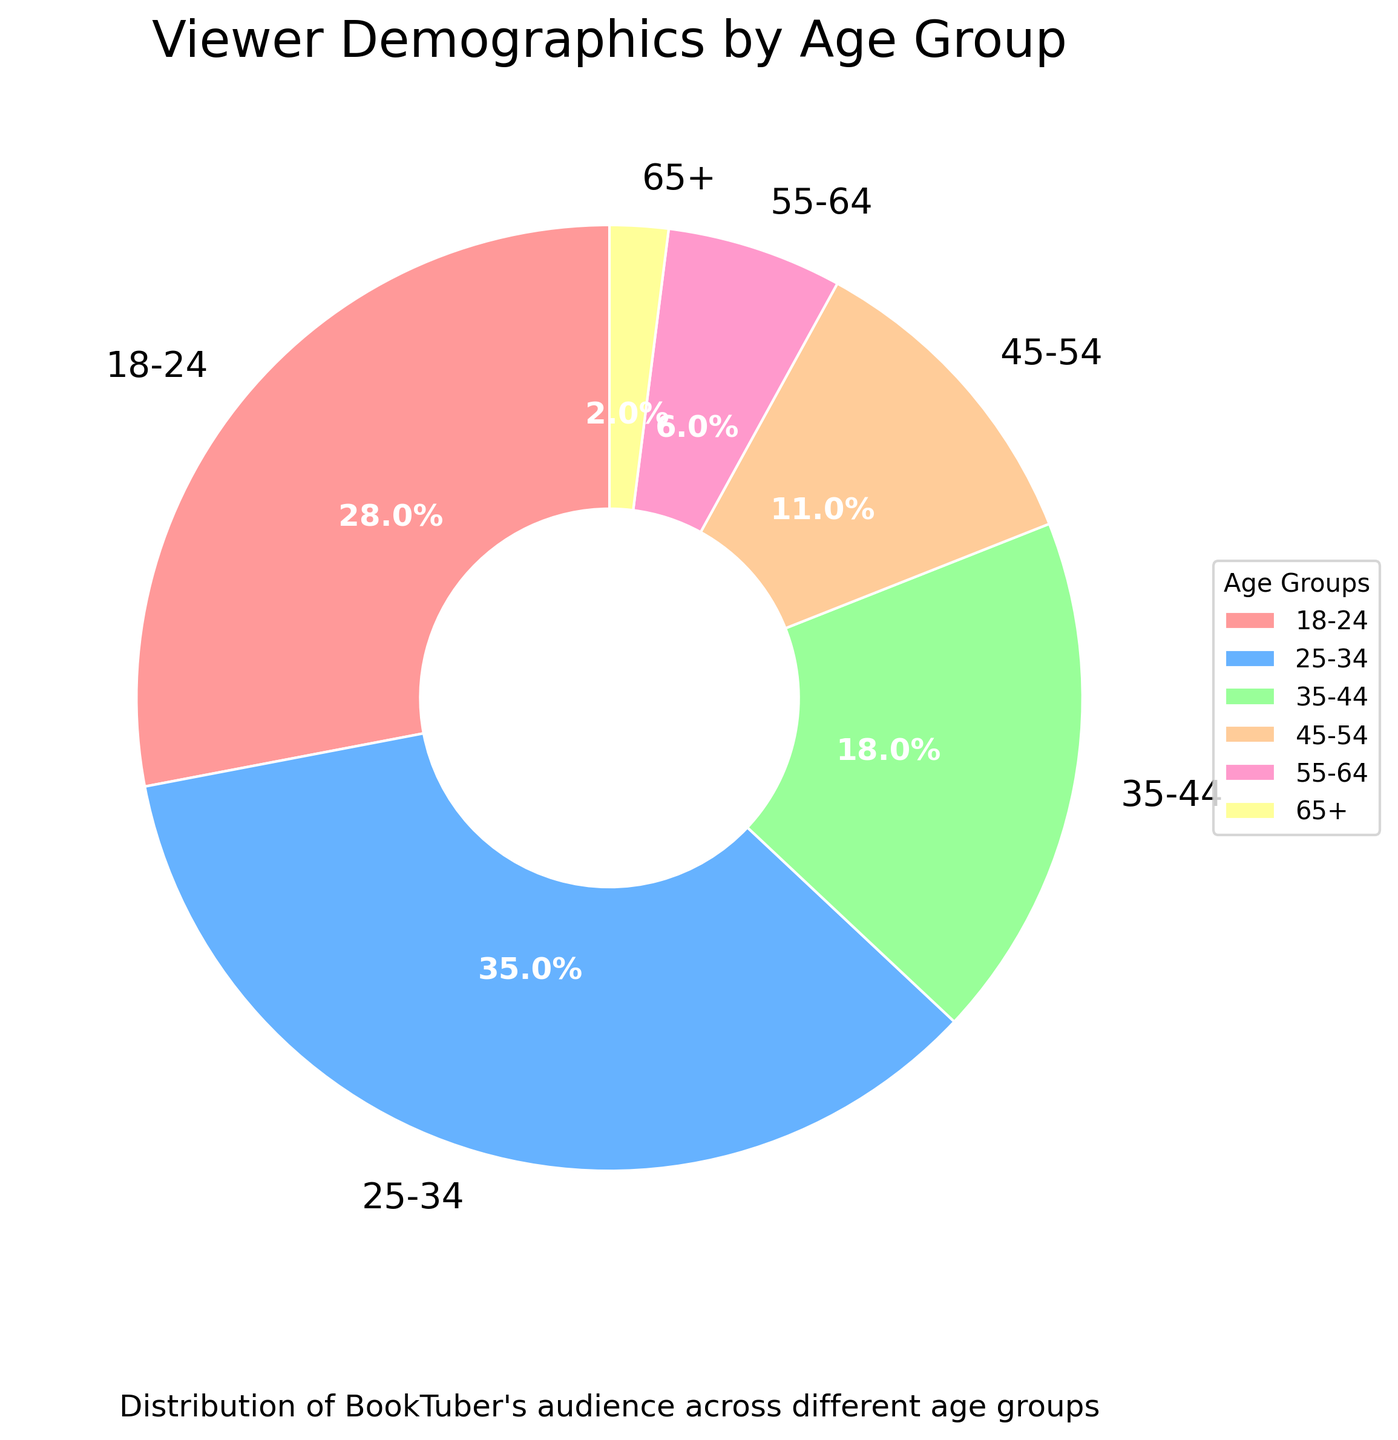What percentage of viewers are aged between 18 and 24? The figure shows the percentage distribution of viewers across different age groups. Locate the segment labeled "18-24" and refer to the associated percentage.
Answer: 28% Which age group constitutes the largest portion of the audience? Look at the pie chart and identify the segment with the largest size by comparing the relative areas of the segments. The label indicates that the 25-34 age group has the largest percentage.
Answer: 25-34 What is the combined percentage of viewers who are over 45 years old? To find the combined percentage of viewers over 45, add up the percentages of the 45-54, 55-64, and 65+ age groups. From the chart, these are 11%, 6%, and 2%, respectively. Calculate the sum: 11 + 6 + 2 = 19%.
Answer: 19% Which age group has the smallest percentage of viewers, and what is that percentage? Observe the pie chart and identify the smallest slice based on size. The label shows that the 65+ age group has the smallest percentage.
Answer: 65+, 2% Is the percentage of viewers aged 25-34 greater than the combined percentage of viewers aged 35-44 and 45-54? First, find the percentage for the 25-34 age group, which is 35%. Next, find the combined percentage of the 35-44 and 45-54 age groups, which are 18% and 11%, respectively. Add these: 18 + 11 = 29%. Compare 35% to 29%, and 35% is greater.
Answer: Yes If you combine the percentages of viewers aged 18-24 and 35-44, will the total be more than half of the total viewers? First, find the percentages of viewers aged 18-24 and 35-44, which are 28% and 18% respectively. Add these together: 28 + 18 = 46%. Since 46% is less than 50%, it is not more than half.
Answer: No What colors correspond to the 18-24 and 25-34 age groups in the pie chart? Refer to the visual attributes of the pie chart. The segment for the 18-24 age group is red, and the segment for the 25-34 age group is blue.
Answer: Red, Blue What is the difference in percentage between viewers aged 35-44 and those aged 45-54? Identify the percentages for the two age groups: 35-44 is 18% and 45-54 is 11%. Subtract the smaller percentage from the larger: 18 - 11 = 7%.
Answer: 7% What is the average percentage of viewers in the 35-44, 45-54, and 55-64 age groups? Find the percentages for these age groups: 35-44 is 18%, 45-54 is 11%, and 55-64 is 6%. Add these together: 18 + 11 + 6 = 35. Then, divide by the number of groups: 35 / 3 ≈ 11.67%.
Answer: 11.67% If you had to describe the distribution of book lovers over 35 by percentages, what would you say? To describe the distribution, add the percentages of all age groups over 35: 35-44 (18%), 45-54 (11%), 55-64 (6%), and 65+ (2%). The combined percentage is 18 + 11 + 6 + 2 = 37%.
Answer: 37% 